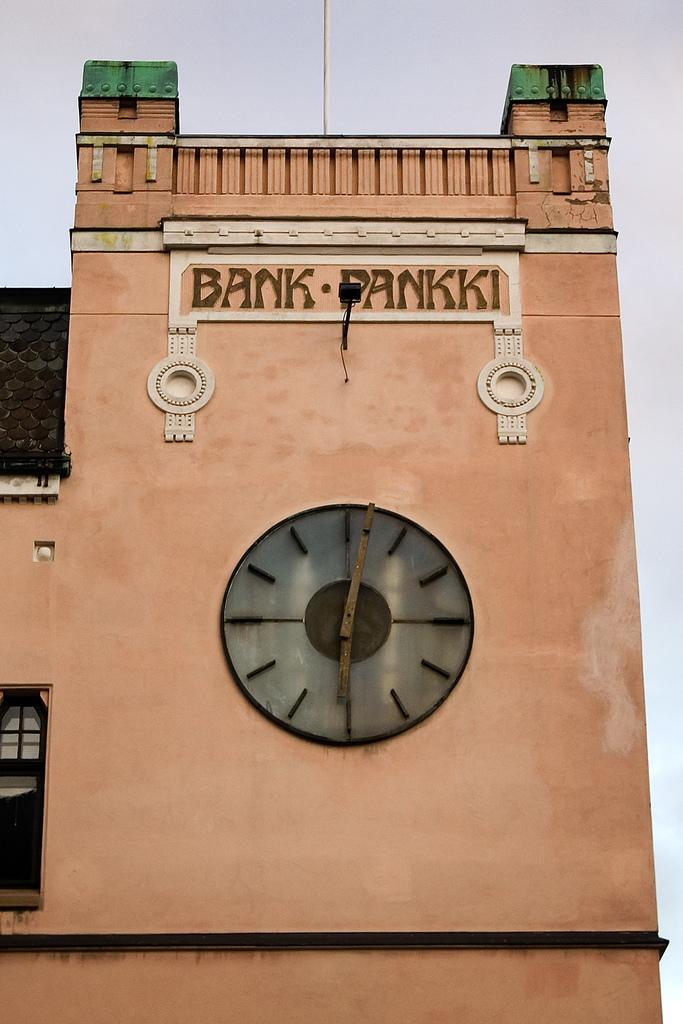<image>
Give a short and clear explanation of the subsequent image. A clock tower attached to the bank of Pankki. 